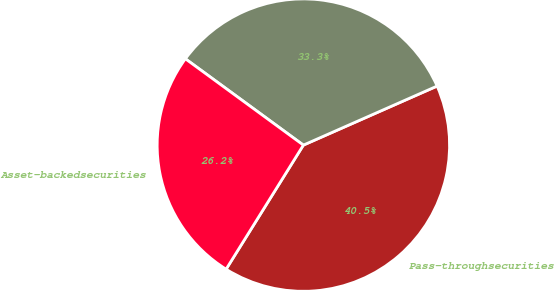Convert chart. <chart><loc_0><loc_0><loc_500><loc_500><pie_chart><fcel>Pass-throughsecurities<fcel>Unnamed: 1<fcel>Asset-backedsecurities<nl><fcel>40.48%<fcel>33.33%<fcel>26.19%<nl></chart> 